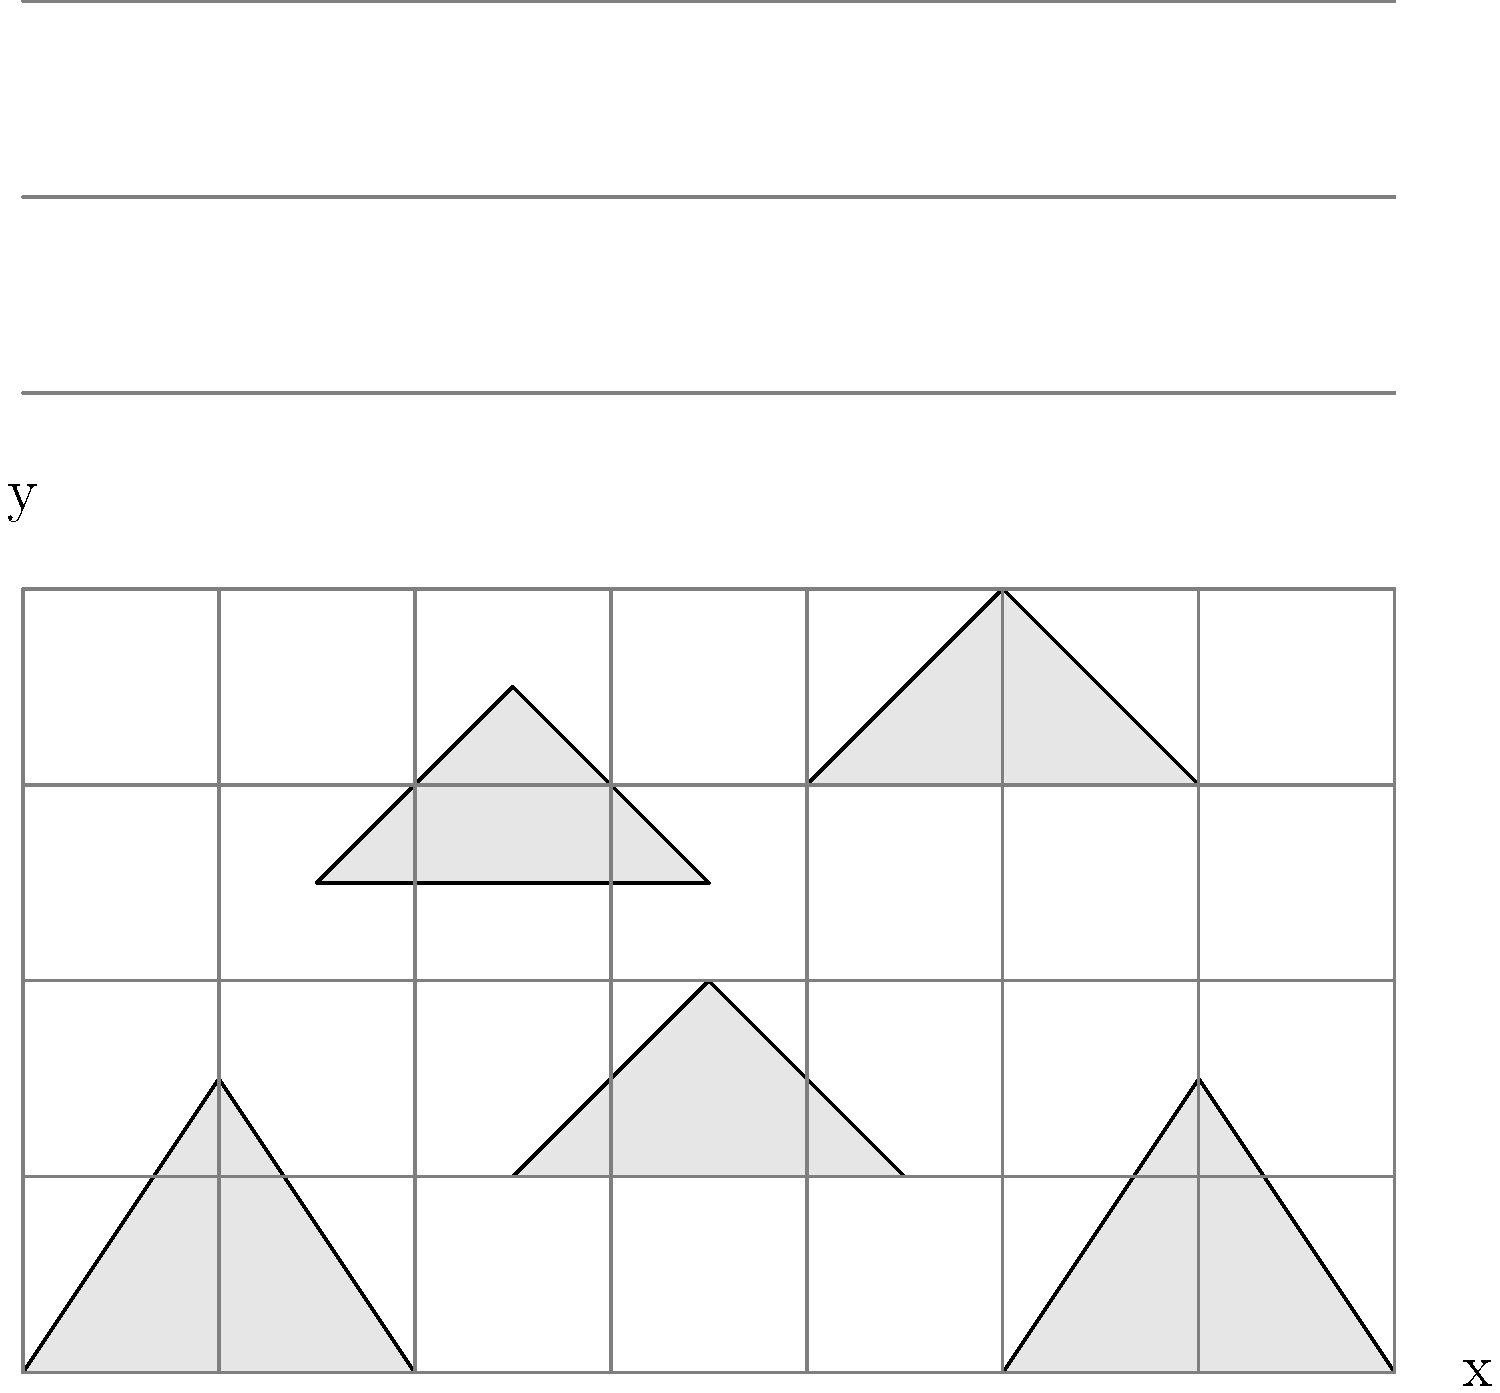As a paleontologist, you're presented with scattered bone fragments from a newly discovered dinosaur species. The image shows five bone fragments plotted on a grid. Based on their positions and shapes, which two fragments are most likely to be adjacent parts of the same bone in the reconstructed skeleton? To determine which two bone fragments are most likely to be adjacent parts of the same bone, we need to analyze their shapes, sizes, and relative positions. Let's approach this step-by-step:

1. Identify the fragments:
   Fragment A: (0,0)--(20,30)--(40,0)
   Fragment B: (50,20)--(70,40)--(90,20)
   Fragment C: (100,0)--(120,30)--(140,0)
   Fragment D: (30,50)--(50,70)--(70,50)
   Fragment E: (80,60)--(100,80)--(120,60)

2. Analyze shapes:
   Fragments A and C have similar triangular shapes with a flat base and a peak.
   Fragments B, D, and E have more elongated, curved shapes.

3. Consider sizes:
   Fragments A and C are of similar size.
   Fragments B, D, and E are also of comparable sizes to each other.

4. Examine relative positions:
   Fragments A and C are at the same vertical level (y=0 to y=30).
   There's a gap between A and C that could accommodate fragment B.

5. Evaluate potential connections:
   The right edge of A (40,0) to (20,30) could potentially connect with the left edge of B (50,20) to (70,40).
   The right edge of B (90,20) to (70,40) could potentially connect with the left edge of C (100,0) to (120,30).

6. Consider biological plausibility:
   In dinosaur skeletons, long bones often have wider ends (epiphyses) connected by a narrower shaft (diaphysis).
   The combination of A, B, and C could represent such a bone structure.

Based on this analysis, fragments A, B, and C are the most likely to be adjacent parts of the same bone. However, the question asks for two fragments, so we need to choose the two that are most directly adjacent.
Answer: Fragments B and C 